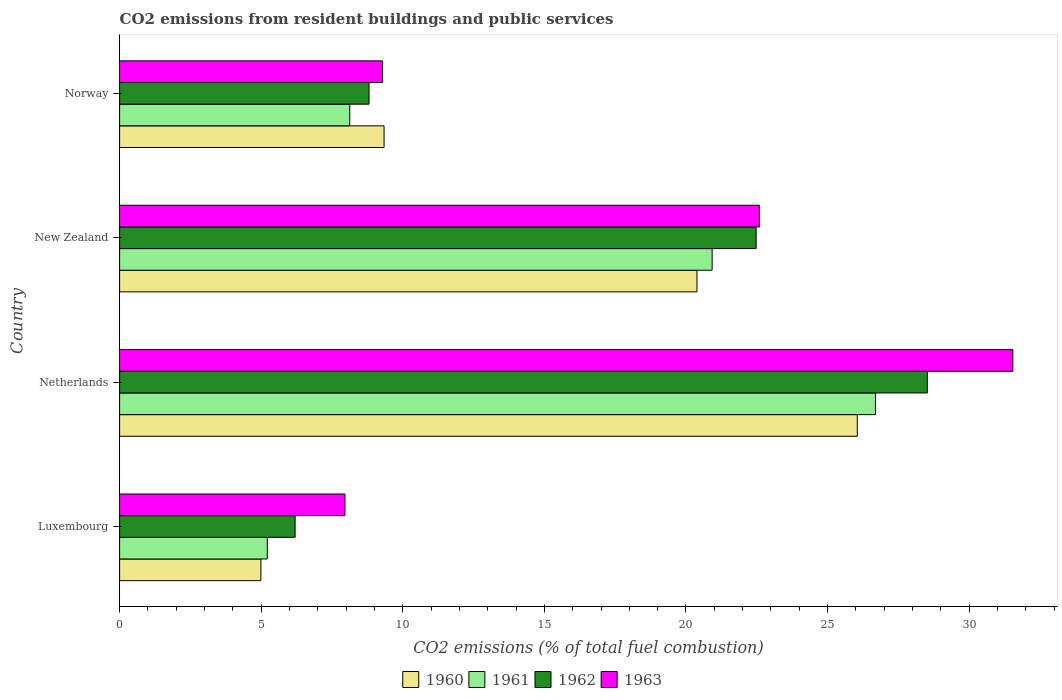How many groups of bars are there?
Your response must be concise. 4. How many bars are there on the 2nd tick from the top?
Give a very brief answer. 4. What is the label of the 2nd group of bars from the top?
Give a very brief answer. New Zealand. What is the total CO2 emitted in 1960 in Norway?
Your response must be concise. 9.34. Across all countries, what is the maximum total CO2 emitted in 1962?
Provide a succinct answer. 28.52. Across all countries, what is the minimum total CO2 emitted in 1963?
Offer a very short reply. 7.96. In which country was the total CO2 emitted in 1962 maximum?
Your answer should be compact. Netherlands. In which country was the total CO2 emitted in 1963 minimum?
Keep it short and to the point. Luxembourg. What is the total total CO2 emitted in 1963 in the graph?
Your answer should be compact. 71.38. What is the difference between the total CO2 emitted in 1960 in Luxembourg and that in Norway?
Keep it short and to the point. -4.35. What is the difference between the total CO2 emitted in 1963 in Netherlands and the total CO2 emitted in 1962 in Norway?
Provide a succinct answer. 22.73. What is the average total CO2 emitted in 1961 per country?
Your answer should be very brief. 15.24. What is the difference between the total CO2 emitted in 1960 and total CO2 emitted in 1962 in New Zealand?
Provide a short and direct response. -2.09. What is the ratio of the total CO2 emitted in 1960 in Luxembourg to that in Norway?
Give a very brief answer. 0.53. Is the total CO2 emitted in 1962 in Luxembourg less than that in New Zealand?
Your answer should be very brief. Yes. Is the difference between the total CO2 emitted in 1960 in Luxembourg and Netherlands greater than the difference between the total CO2 emitted in 1962 in Luxembourg and Netherlands?
Make the answer very short. Yes. What is the difference between the highest and the second highest total CO2 emitted in 1961?
Keep it short and to the point. 5.77. What is the difference between the highest and the lowest total CO2 emitted in 1962?
Offer a very short reply. 22.33. Is the sum of the total CO2 emitted in 1963 in Luxembourg and New Zealand greater than the maximum total CO2 emitted in 1960 across all countries?
Ensure brevity in your answer.  Yes. Is it the case that in every country, the sum of the total CO2 emitted in 1961 and total CO2 emitted in 1962 is greater than the sum of total CO2 emitted in 1960 and total CO2 emitted in 1963?
Provide a short and direct response. No. What does the 3rd bar from the top in Luxembourg represents?
Make the answer very short. 1961. What does the 4th bar from the bottom in Netherlands represents?
Keep it short and to the point. 1963. Is it the case that in every country, the sum of the total CO2 emitted in 1960 and total CO2 emitted in 1963 is greater than the total CO2 emitted in 1962?
Provide a short and direct response. Yes. How many bars are there?
Provide a succinct answer. 16. Are all the bars in the graph horizontal?
Offer a very short reply. Yes. How many countries are there in the graph?
Your answer should be compact. 4. Are the values on the major ticks of X-axis written in scientific E-notation?
Keep it short and to the point. No. Does the graph contain any zero values?
Provide a succinct answer. No. Where does the legend appear in the graph?
Make the answer very short. Bottom center. What is the title of the graph?
Your answer should be very brief. CO2 emissions from resident buildings and public services. What is the label or title of the X-axis?
Offer a terse response. CO2 emissions (% of total fuel combustion). What is the CO2 emissions (% of total fuel combustion) of 1960 in Luxembourg?
Give a very brief answer. 4.99. What is the CO2 emissions (% of total fuel combustion) in 1961 in Luxembourg?
Your answer should be very brief. 5.21. What is the CO2 emissions (% of total fuel combustion) in 1962 in Luxembourg?
Provide a short and direct response. 6.2. What is the CO2 emissions (% of total fuel combustion) in 1963 in Luxembourg?
Provide a succinct answer. 7.96. What is the CO2 emissions (% of total fuel combustion) of 1960 in Netherlands?
Offer a very short reply. 26.05. What is the CO2 emissions (% of total fuel combustion) of 1961 in Netherlands?
Your response must be concise. 26.69. What is the CO2 emissions (% of total fuel combustion) of 1962 in Netherlands?
Offer a terse response. 28.52. What is the CO2 emissions (% of total fuel combustion) in 1963 in Netherlands?
Your response must be concise. 31.54. What is the CO2 emissions (% of total fuel combustion) of 1960 in New Zealand?
Provide a succinct answer. 20.39. What is the CO2 emissions (% of total fuel combustion) in 1961 in New Zealand?
Make the answer very short. 20.92. What is the CO2 emissions (% of total fuel combustion) in 1962 in New Zealand?
Provide a short and direct response. 22.48. What is the CO2 emissions (% of total fuel combustion) in 1963 in New Zealand?
Give a very brief answer. 22.59. What is the CO2 emissions (% of total fuel combustion) of 1960 in Norway?
Your answer should be compact. 9.34. What is the CO2 emissions (% of total fuel combustion) of 1961 in Norway?
Offer a terse response. 8.13. What is the CO2 emissions (% of total fuel combustion) of 1962 in Norway?
Make the answer very short. 8.81. What is the CO2 emissions (% of total fuel combustion) of 1963 in Norway?
Provide a short and direct response. 9.28. Across all countries, what is the maximum CO2 emissions (% of total fuel combustion) of 1960?
Give a very brief answer. 26.05. Across all countries, what is the maximum CO2 emissions (% of total fuel combustion) of 1961?
Give a very brief answer. 26.69. Across all countries, what is the maximum CO2 emissions (% of total fuel combustion) in 1962?
Offer a very short reply. 28.52. Across all countries, what is the maximum CO2 emissions (% of total fuel combustion) in 1963?
Your answer should be very brief. 31.54. Across all countries, what is the minimum CO2 emissions (% of total fuel combustion) of 1960?
Provide a short and direct response. 4.99. Across all countries, what is the minimum CO2 emissions (% of total fuel combustion) of 1961?
Give a very brief answer. 5.21. Across all countries, what is the minimum CO2 emissions (% of total fuel combustion) of 1962?
Give a very brief answer. 6.2. Across all countries, what is the minimum CO2 emissions (% of total fuel combustion) of 1963?
Your response must be concise. 7.96. What is the total CO2 emissions (% of total fuel combustion) in 1960 in the graph?
Provide a succinct answer. 60.77. What is the total CO2 emissions (% of total fuel combustion) in 1961 in the graph?
Ensure brevity in your answer.  60.96. What is the total CO2 emissions (% of total fuel combustion) in 1962 in the graph?
Provide a succinct answer. 66.01. What is the total CO2 emissions (% of total fuel combustion) of 1963 in the graph?
Offer a very short reply. 71.38. What is the difference between the CO2 emissions (% of total fuel combustion) of 1960 in Luxembourg and that in Netherlands?
Offer a terse response. -21.06. What is the difference between the CO2 emissions (% of total fuel combustion) of 1961 in Luxembourg and that in Netherlands?
Provide a short and direct response. -21.48. What is the difference between the CO2 emissions (% of total fuel combustion) of 1962 in Luxembourg and that in Netherlands?
Your answer should be very brief. -22.33. What is the difference between the CO2 emissions (% of total fuel combustion) in 1963 in Luxembourg and that in Netherlands?
Offer a very short reply. -23.58. What is the difference between the CO2 emissions (% of total fuel combustion) in 1960 in Luxembourg and that in New Zealand?
Ensure brevity in your answer.  -15.4. What is the difference between the CO2 emissions (% of total fuel combustion) of 1961 in Luxembourg and that in New Zealand?
Make the answer very short. -15.71. What is the difference between the CO2 emissions (% of total fuel combustion) in 1962 in Luxembourg and that in New Zealand?
Your answer should be very brief. -16.28. What is the difference between the CO2 emissions (% of total fuel combustion) of 1963 in Luxembourg and that in New Zealand?
Ensure brevity in your answer.  -14.63. What is the difference between the CO2 emissions (% of total fuel combustion) in 1960 in Luxembourg and that in Norway?
Ensure brevity in your answer.  -4.35. What is the difference between the CO2 emissions (% of total fuel combustion) in 1961 in Luxembourg and that in Norway?
Keep it short and to the point. -2.91. What is the difference between the CO2 emissions (% of total fuel combustion) in 1962 in Luxembourg and that in Norway?
Your answer should be very brief. -2.61. What is the difference between the CO2 emissions (% of total fuel combustion) in 1963 in Luxembourg and that in Norway?
Ensure brevity in your answer.  -1.33. What is the difference between the CO2 emissions (% of total fuel combustion) in 1960 in Netherlands and that in New Zealand?
Offer a terse response. 5.66. What is the difference between the CO2 emissions (% of total fuel combustion) of 1961 in Netherlands and that in New Zealand?
Offer a very short reply. 5.77. What is the difference between the CO2 emissions (% of total fuel combustion) of 1962 in Netherlands and that in New Zealand?
Your answer should be very brief. 6.05. What is the difference between the CO2 emissions (% of total fuel combustion) in 1963 in Netherlands and that in New Zealand?
Your answer should be compact. 8.95. What is the difference between the CO2 emissions (% of total fuel combustion) in 1960 in Netherlands and that in Norway?
Offer a very short reply. 16.71. What is the difference between the CO2 emissions (% of total fuel combustion) of 1961 in Netherlands and that in Norway?
Make the answer very short. 18.56. What is the difference between the CO2 emissions (% of total fuel combustion) of 1962 in Netherlands and that in Norway?
Offer a terse response. 19.72. What is the difference between the CO2 emissions (% of total fuel combustion) of 1963 in Netherlands and that in Norway?
Keep it short and to the point. 22.26. What is the difference between the CO2 emissions (% of total fuel combustion) of 1960 in New Zealand and that in Norway?
Offer a very short reply. 11.05. What is the difference between the CO2 emissions (% of total fuel combustion) in 1961 in New Zealand and that in Norway?
Your answer should be very brief. 12.8. What is the difference between the CO2 emissions (% of total fuel combustion) of 1962 in New Zealand and that in Norway?
Ensure brevity in your answer.  13.67. What is the difference between the CO2 emissions (% of total fuel combustion) in 1963 in New Zealand and that in Norway?
Make the answer very short. 13.31. What is the difference between the CO2 emissions (% of total fuel combustion) of 1960 in Luxembourg and the CO2 emissions (% of total fuel combustion) of 1961 in Netherlands?
Your response must be concise. -21.7. What is the difference between the CO2 emissions (% of total fuel combustion) in 1960 in Luxembourg and the CO2 emissions (% of total fuel combustion) in 1962 in Netherlands?
Your answer should be compact. -23.54. What is the difference between the CO2 emissions (% of total fuel combustion) of 1960 in Luxembourg and the CO2 emissions (% of total fuel combustion) of 1963 in Netherlands?
Keep it short and to the point. -26.55. What is the difference between the CO2 emissions (% of total fuel combustion) in 1961 in Luxembourg and the CO2 emissions (% of total fuel combustion) in 1962 in Netherlands?
Your response must be concise. -23.31. What is the difference between the CO2 emissions (% of total fuel combustion) in 1961 in Luxembourg and the CO2 emissions (% of total fuel combustion) in 1963 in Netherlands?
Offer a terse response. -26.33. What is the difference between the CO2 emissions (% of total fuel combustion) of 1962 in Luxembourg and the CO2 emissions (% of total fuel combustion) of 1963 in Netherlands?
Offer a very short reply. -25.34. What is the difference between the CO2 emissions (% of total fuel combustion) in 1960 in Luxembourg and the CO2 emissions (% of total fuel combustion) in 1961 in New Zealand?
Make the answer very short. -15.94. What is the difference between the CO2 emissions (% of total fuel combustion) in 1960 in Luxembourg and the CO2 emissions (% of total fuel combustion) in 1962 in New Zealand?
Provide a succinct answer. -17.49. What is the difference between the CO2 emissions (% of total fuel combustion) in 1960 in Luxembourg and the CO2 emissions (% of total fuel combustion) in 1963 in New Zealand?
Your answer should be very brief. -17.6. What is the difference between the CO2 emissions (% of total fuel combustion) in 1961 in Luxembourg and the CO2 emissions (% of total fuel combustion) in 1962 in New Zealand?
Give a very brief answer. -17.26. What is the difference between the CO2 emissions (% of total fuel combustion) in 1961 in Luxembourg and the CO2 emissions (% of total fuel combustion) in 1963 in New Zealand?
Offer a terse response. -17.38. What is the difference between the CO2 emissions (% of total fuel combustion) in 1962 in Luxembourg and the CO2 emissions (% of total fuel combustion) in 1963 in New Zealand?
Make the answer very short. -16.39. What is the difference between the CO2 emissions (% of total fuel combustion) in 1960 in Luxembourg and the CO2 emissions (% of total fuel combustion) in 1961 in Norway?
Offer a terse response. -3.14. What is the difference between the CO2 emissions (% of total fuel combustion) of 1960 in Luxembourg and the CO2 emissions (% of total fuel combustion) of 1962 in Norway?
Give a very brief answer. -3.82. What is the difference between the CO2 emissions (% of total fuel combustion) in 1960 in Luxembourg and the CO2 emissions (% of total fuel combustion) in 1963 in Norway?
Provide a succinct answer. -4.3. What is the difference between the CO2 emissions (% of total fuel combustion) in 1961 in Luxembourg and the CO2 emissions (% of total fuel combustion) in 1962 in Norway?
Your response must be concise. -3.59. What is the difference between the CO2 emissions (% of total fuel combustion) in 1961 in Luxembourg and the CO2 emissions (% of total fuel combustion) in 1963 in Norway?
Provide a succinct answer. -4.07. What is the difference between the CO2 emissions (% of total fuel combustion) in 1962 in Luxembourg and the CO2 emissions (% of total fuel combustion) in 1963 in Norway?
Provide a short and direct response. -3.09. What is the difference between the CO2 emissions (% of total fuel combustion) of 1960 in Netherlands and the CO2 emissions (% of total fuel combustion) of 1961 in New Zealand?
Your answer should be very brief. 5.13. What is the difference between the CO2 emissions (% of total fuel combustion) of 1960 in Netherlands and the CO2 emissions (% of total fuel combustion) of 1962 in New Zealand?
Keep it short and to the point. 3.57. What is the difference between the CO2 emissions (% of total fuel combustion) of 1960 in Netherlands and the CO2 emissions (% of total fuel combustion) of 1963 in New Zealand?
Provide a short and direct response. 3.46. What is the difference between the CO2 emissions (% of total fuel combustion) of 1961 in Netherlands and the CO2 emissions (% of total fuel combustion) of 1962 in New Zealand?
Give a very brief answer. 4.21. What is the difference between the CO2 emissions (% of total fuel combustion) of 1961 in Netherlands and the CO2 emissions (% of total fuel combustion) of 1963 in New Zealand?
Ensure brevity in your answer.  4.1. What is the difference between the CO2 emissions (% of total fuel combustion) of 1962 in Netherlands and the CO2 emissions (% of total fuel combustion) of 1963 in New Zealand?
Offer a very short reply. 5.93. What is the difference between the CO2 emissions (% of total fuel combustion) in 1960 in Netherlands and the CO2 emissions (% of total fuel combustion) in 1961 in Norway?
Provide a short and direct response. 17.92. What is the difference between the CO2 emissions (% of total fuel combustion) of 1960 in Netherlands and the CO2 emissions (% of total fuel combustion) of 1962 in Norway?
Your response must be concise. 17.24. What is the difference between the CO2 emissions (% of total fuel combustion) of 1960 in Netherlands and the CO2 emissions (% of total fuel combustion) of 1963 in Norway?
Provide a short and direct response. 16.76. What is the difference between the CO2 emissions (% of total fuel combustion) in 1961 in Netherlands and the CO2 emissions (% of total fuel combustion) in 1962 in Norway?
Your response must be concise. 17.88. What is the difference between the CO2 emissions (% of total fuel combustion) of 1961 in Netherlands and the CO2 emissions (% of total fuel combustion) of 1963 in Norway?
Ensure brevity in your answer.  17.41. What is the difference between the CO2 emissions (% of total fuel combustion) of 1962 in Netherlands and the CO2 emissions (% of total fuel combustion) of 1963 in Norway?
Provide a short and direct response. 19.24. What is the difference between the CO2 emissions (% of total fuel combustion) in 1960 in New Zealand and the CO2 emissions (% of total fuel combustion) in 1961 in Norway?
Ensure brevity in your answer.  12.26. What is the difference between the CO2 emissions (% of total fuel combustion) of 1960 in New Zealand and the CO2 emissions (% of total fuel combustion) of 1962 in Norway?
Provide a succinct answer. 11.58. What is the difference between the CO2 emissions (% of total fuel combustion) in 1960 in New Zealand and the CO2 emissions (% of total fuel combustion) in 1963 in Norway?
Give a very brief answer. 11.1. What is the difference between the CO2 emissions (% of total fuel combustion) in 1961 in New Zealand and the CO2 emissions (% of total fuel combustion) in 1962 in Norway?
Offer a very short reply. 12.12. What is the difference between the CO2 emissions (% of total fuel combustion) of 1961 in New Zealand and the CO2 emissions (% of total fuel combustion) of 1963 in Norway?
Your response must be concise. 11.64. What is the difference between the CO2 emissions (% of total fuel combustion) of 1962 in New Zealand and the CO2 emissions (% of total fuel combustion) of 1963 in Norway?
Offer a very short reply. 13.19. What is the average CO2 emissions (% of total fuel combustion) in 1960 per country?
Provide a short and direct response. 15.19. What is the average CO2 emissions (% of total fuel combustion) in 1961 per country?
Offer a terse response. 15.24. What is the average CO2 emissions (% of total fuel combustion) in 1962 per country?
Give a very brief answer. 16.5. What is the average CO2 emissions (% of total fuel combustion) of 1963 per country?
Your answer should be compact. 17.84. What is the difference between the CO2 emissions (% of total fuel combustion) of 1960 and CO2 emissions (% of total fuel combustion) of 1961 in Luxembourg?
Your answer should be compact. -0.23. What is the difference between the CO2 emissions (% of total fuel combustion) of 1960 and CO2 emissions (% of total fuel combustion) of 1962 in Luxembourg?
Provide a succinct answer. -1.21. What is the difference between the CO2 emissions (% of total fuel combustion) of 1960 and CO2 emissions (% of total fuel combustion) of 1963 in Luxembourg?
Provide a succinct answer. -2.97. What is the difference between the CO2 emissions (% of total fuel combustion) in 1961 and CO2 emissions (% of total fuel combustion) in 1962 in Luxembourg?
Give a very brief answer. -0.98. What is the difference between the CO2 emissions (% of total fuel combustion) of 1961 and CO2 emissions (% of total fuel combustion) of 1963 in Luxembourg?
Make the answer very short. -2.74. What is the difference between the CO2 emissions (% of total fuel combustion) in 1962 and CO2 emissions (% of total fuel combustion) in 1963 in Luxembourg?
Provide a short and direct response. -1.76. What is the difference between the CO2 emissions (% of total fuel combustion) in 1960 and CO2 emissions (% of total fuel combustion) in 1961 in Netherlands?
Your answer should be compact. -0.64. What is the difference between the CO2 emissions (% of total fuel combustion) in 1960 and CO2 emissions (% of total fuel combustion) in 1962 in Netherlands?
Give a very brief answer. -2.47. What is the difference between the CO2 emissions (% of total fuel combustion) of 1960 and CO2 emissions (% of total fuel combustion) of 1963 in Netherlands?
Make the answer very short. -5.49. What is the difference between the CO2 emissions (% of total fuel combustion) of 1961 and CO2 emissions (% of total fuel combustion) of 1962 in Netherlands?
Offer a very short reply. -1.83. What is the difference between the CO2 emissions (% of total fuel combustion) in 1961 and CO2 emissions (% of total fuel combustion) in 1963 in Netherlands?
Provide a succinct answer. -4.85. What is the difference between the CO2 emissions (% of total fuel combustion) in 1962 and CO2 emissions (% of total fuel combustion) in 1963 in Netherlands?
Your answer should be very brief. -3.02. What is the difference between the CO2 emissions (% of total fuel combustion) in 1960 and CO2 emissions (% of total fuel combustion) in 1961 in New Zealand?
Offer a terse response. -0.54. What is the difference between the CO2 emissions (% of total fuel combustion) in 1960 and CO2 emissions (% of total fuel combustion) in 1962 in New Zealand?
Your answer should be very brief. -2.09. What is the difference between the CO2 emissions (% of total fuel combustion) in 1960 and CO2 emissions (% of total fuel combustion) in 1963 in New Zealand?
Make the answer very short. -2.2. What is the difference between the CO2 emissions (% of total fuel combustion) in 1961 and CO2 emissions (% of total fuel combustion) in 1962 in New Zealand?
Provide a succinct answer. -1.55. What is the difference between the CO2 emissions (% of total fuel combustion) in 1961 and CO2 emissions (% of total fuel combustion) in 1963 in New Zealand?
Ensure brevity in your answer.  -1.67. What is the difference between the CO2 emissions (% of total fuel combustion) in 1962 and CO2 emissions (% of total fuel combustion) in 1963 in New Zealand?
Your response must be concise. -0.12. What is the difference between the CO2 emissions (% of total fuel combustion) of 1960 and CO2 emissions (% of total fuel combustion) of 1961 in Norway?
Your response must be concise. 1.21. What is the difference between the CO2 emissions (% of total fuel combustion) of 1960 and CO2 emissions (% of total fuel combustion) of 1962 in Norway?
Give a very brief answer. 0.53. What is the difference between the CO2 emissions (% of total fuel combustion) of 1960 and CO2 emissions (% of total fuel combustion) of 1963 in Norway?
Provide a short and direct response. 0.05. What is the difference between the CO2 emissions (% of total fuel combustion) in 1961 and CO2 emissions (% of total fuel combustion) in 1962 in Norway?
Your answer should be compact. -0.68. What is the difference between the CO2 emissions (% of total fuel combustion) of 1961 and CO2 emissions (% of total fuel combustion) of 1963 in Norway?
Your response must be concise. -1.16. What is the difference between the CO2 emissions (% of total fuel combustion) of 1962 and CO2 emissions (% of total fuel combustion) of 1963 in Norway?
Ensure brevity in your answer.  -0.48. What is the ratio of the CO2 emissions (% of total fuel combustion) in 1960 in Luxembourg to that in Netherlands?
Keep it short and to the point. 0.19. What is the ratio of the CO2 emissions (% of total fuel combustion) of 1961 in Luxembourg to that in Netherlands?
Provide a short and direct response. 0.2. What is the ratio of the CO2 emissions (% of total fuel combustion) of 1962 in Luxembourg to that in Netherlands?
Ensure brevity in your answer.  0.22. What is the ratio of the CO2 emissions (% of total fuel combustion) of 1963 in Luxembourg to that in Netherlands?
Provide a short and direct response. 0.25. What is the ratio of the CO2 emissions (% of total fuel combustion) of 1960 in Luxembourg to that in New Zealand?
Provide a short and direct response. 0.24. What is the ratio of the CO2 emissions (% of total fuel combustion) in 1961 in Luxembourg to that in New Zealand?
Offer a terse response. 0.25. What is the ratio of the CO2 emissions (% of total fuel combustion) of 1962 in Luxembourg to that in New Zealand?
Offer a very short reply. 0.28. What is the ratio of the CO2 emissions (% of total fuel combustion) in 1963 in Luxembourg to that in New Zealand?
Offer a very short reply. 0.35. What is the ratio of the CO2 emissions (% of total fuel combustion) of 1960 in Luxembourg to that in Norway?
Ensure brevity in your answer.  0.53. What is the ratio of the CO2 emissions (% of total fuel combustion) of 1961 in Luxembourg to that in Norway?
Keep it short and to the point. 0.64. What is the ratio of the CO2 emissions (% of total fuel combustion) in 1962 in Luxembourg to that in Norway?
Give a very brief answer. 0.7. What is the ratio of the CO2 emissions (% of total fuel combustion) in 1960 in Netherlands to that in New Zealand?
Provide a short and direct response. 1.28. What is the ratio of the CO2 emissions (% of total fuel combustion) of 1961 in Netherlands to that in New Zealand?
Your answer should be very brief. 1.28. What is the ratio of the CO2 emissions (% of total fuel combustion) of 1962 in Netherlands to that in New Zealand?
Your response must be concise. 1.27. What is the ratio of the CO2 emissions (% of total fuel combustion) in 1963 in Netherlands to that in New Zealand?
Offer a terse response. 1.4. What is the ratio of the CO2 emissions (% of total fuel combustion) of 1960 in Netherlands to that in Norway?
Your response must be concise. 2.79. What is the ratio of the CO2 emissions (% of total fuel combustion) in 1961 in Netherlands to that in Norway?
Give a very brief answer. 3.28. What is the ratio of the CO2 emissions (% of total fuel combustion) in 1962 in Netherlands to that in Norway?
Your response must be concise. 3.24. What is the ratio of the CO2 emissions (% of total fuel combustion) of 1963 in Netherlands to that in Norway?
Ensure brevity in your answer.  3.4. What is the ratio of the CO2 emissions (% of total fuel combustion) of 1960 in New Zealand to that in Norway?
Keep it short and to the point. 2.18. What is the ratio of the CO2 emissions (% of total fuel combustion) in 1961 in New Zealand to that in Norway?
Your answer should be very brief. 2.57. What is the ratio of the CO2 emissions (% of total fuel combustion) of 1962 in New Zealand to that in Norway?
Offer a terse response. 2.55. What is the ratio of the CO2 emissions (% of total fuel combustion) of 1963 in New Zealand to that in Norway?
Provide a succinct answer. 2.43. What is the difference between the highest and the second highest CO2 emissions (% of total fuel combustion) of 1960?
Provide a short and direct response. 5.66. What is the difference between the highest and the second highest CO2 emissions (% of total fuel combustion) of 1961?
Your response must be concise. 5.77. What is the difference between the highest and the second highest CO2 emissions (% of total fuel combustion) in 1962?
Keep it short and to the point. 6.05. What is the difference between the highest and the second highest CO2 emissions (% of total fuel combustion) of 1963?
Provide a succinct answer. 8.95. What is the difference between the highest and the lowest CO2 emissions (% of total fuel combustion) in 1960?
Ensure brevity in your answer.  21.06. What is the difference between the highest and the lowest CO2 emissions (% of total fuel combustion) of 1961?
Your response must be concise. 21.48. What is the difference between the highest and the lowest CO2 emissions (% of total fuel combustion) in 1962?
Provide a succinct answer. 22.33. What is the difference between the highest and the lowest CO2 emissions (% of total fuel combustion) of 1963?
Make the answer very short. 23.58. 